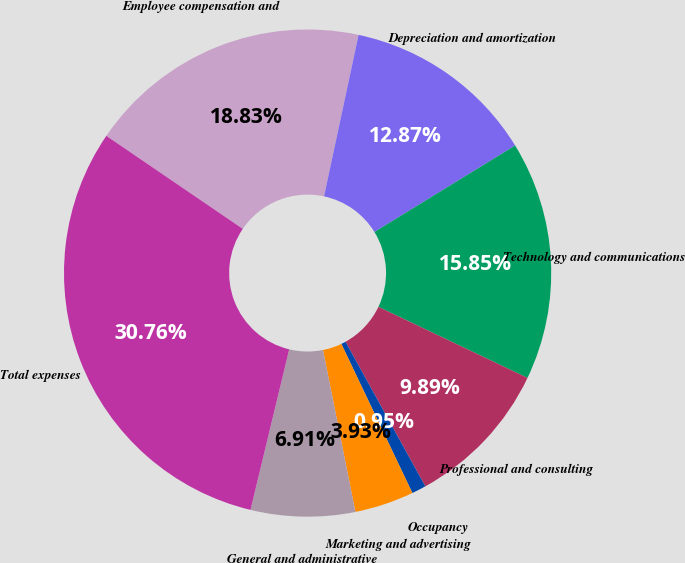Convert chart to OTSL. <chart><loc_0><loc_0><loc_500><loc_500><pie_chart><fcel>Employee compensation and<fcel>Depreciation and amortization<fcel>Technology and communications<fcel>Professional and consulting<fcel>Occupancy<fcel>Marketing and advertising<fcel>General and administrative<fcel>Total expenses<nl><fcel>18.83%<fcel>12.87%<fcel>15.85%<fcel>9.89%<fcel>0.95%<fcel>3.93%<fcel>6.91%<fcel>30.75%<nl></chart> 